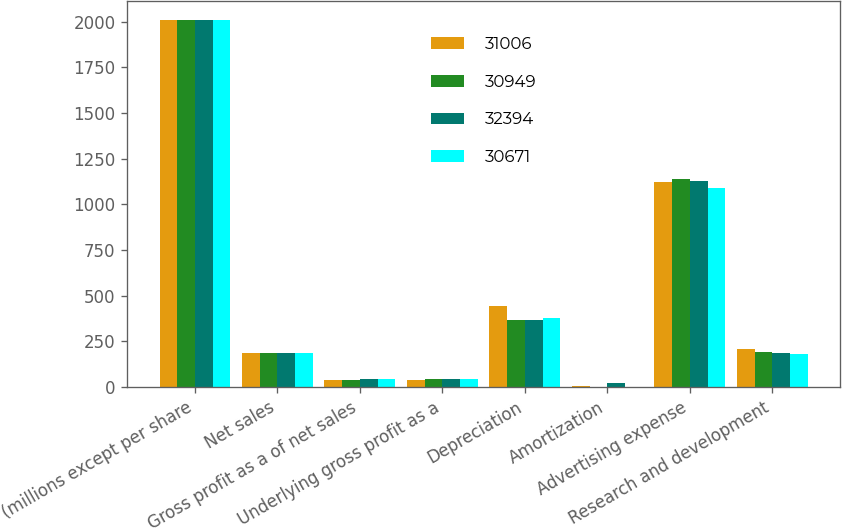<chart> <loc_0><loc_0><loc_500><loc_500><stacked_bar_chart><ecel><fcel>(millions except per share<fcel>Net sales<fcel>Gross profit as a of net sales<fcel>Underlying gross profit as a<fcel>Depreciation<fcel>Amortization<fcel>Advertising expense<fcel>Research and development<nl><fcel>31006<fcel>2012<fcel>189.5<fcel>38.3<fcel>40.1<fcel>444<fcel>4<fcel>1120<fcel>206<nl><fcel>30949<fcel>2011<fcel>189.5<fcel>39<fcel>41.9<fcel>367<fcel>2<fcel>1138<fcel>192<nl><fcel>32394<fcel>2010<fcel>189.5<fcel>43.1<fcel>43<fcel>370<fcel>22<fcel>1130<fcel>187<nl><fcel>30671<fcel>2009<fcel>189.5<fcel>43<fcel>42.7<fcel>381<fcel>3<fcel>1091<fcel>181<nl></chart> 